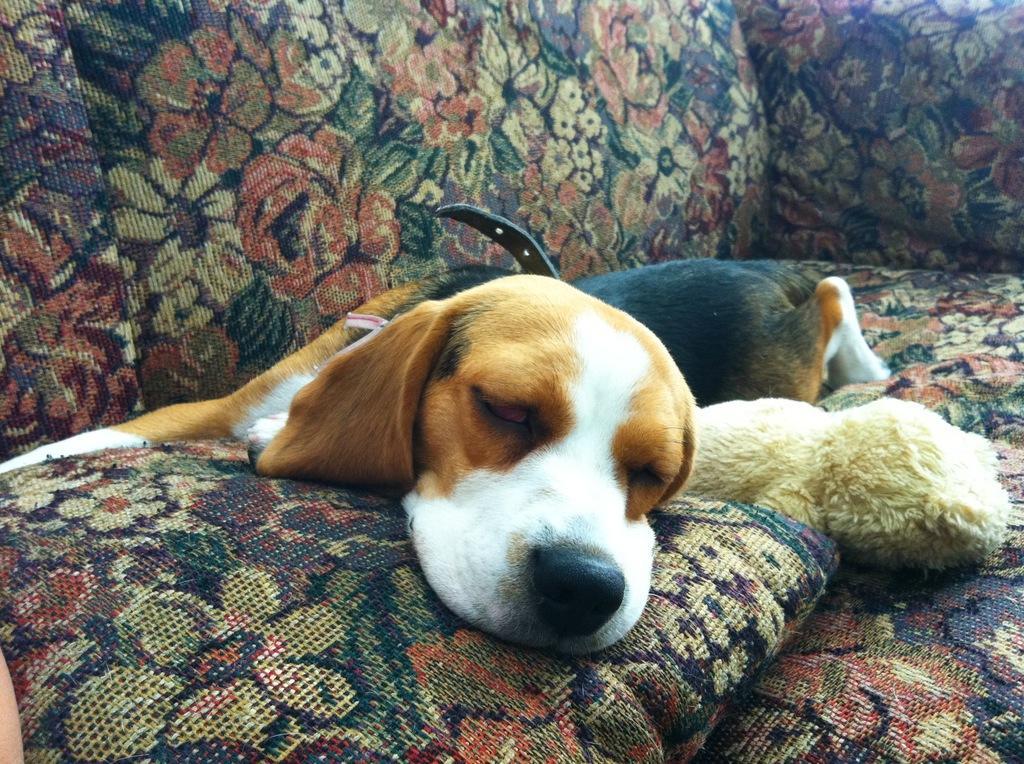How would you summarize this image in a sentence or two? In this picture we can see a toy, pillow, dog with a belt and this dog is sleeping on a sofa. 